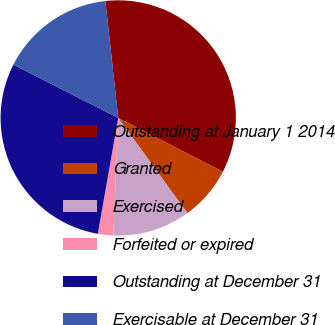Convert chart. <chart><loc_0><loc_0><loc_500><loc_500><pie_chart><fcel>Outstanding at January 1 2014<fcel>Granted<fcel>Exercised<fcel>Forfeited or expired<fcel>Outstanding at December 31<fcel>Exercisable at December 31<nl><fcel>34.3%<fcel>7.44%<fcel>10.66%<fcel>2.12%<fcel>29.7%<fcel>15.78%<nl></chart> 